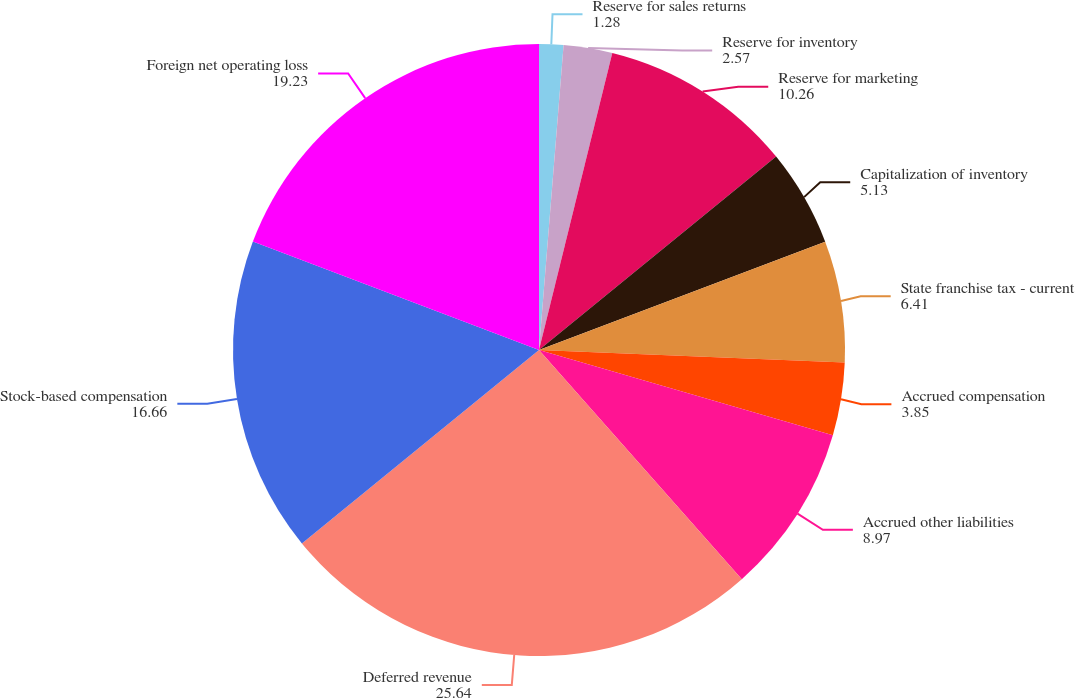Convert chart. <chart><loc_0><loc_0><loc_500><loc_500><pie_chart><fcel>Reserve for sales returns<fcel>Reserve for inventory<fcel>Reserve for marketing<fcel>Capitalization of inventory<fcel>State franchise tax - current<fcel>Accrued compensation<fcel>Accrued other liabilities<fcel>Deferred revenue<fcel>Stock-based compensation<fcel>Foreign net operating loss<nl><fcel>1.28%<fcel>2.57%<fcel>10.26%<fcel>5.13%<fcel>6.41%<fcel>3.85%<fcel>8.97%<fcel>25.64%<fcel>16.66%<fcel>19.23%<nl></chart> 